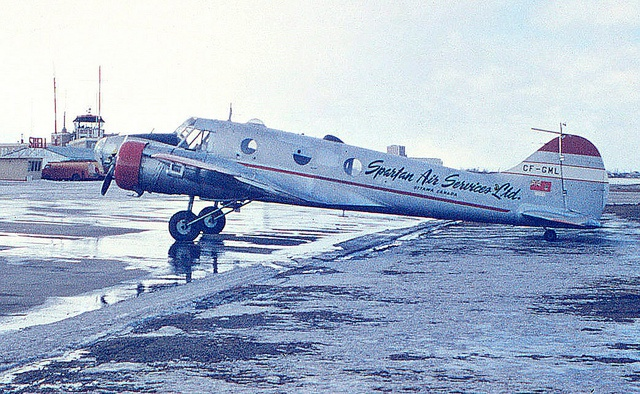Describe the objects in this image and their specific colors. I can see airplane in ivory, darkgray, navy, and lightblue tones and truck in ivory, navy, purple, and darkgray tones in this image. 